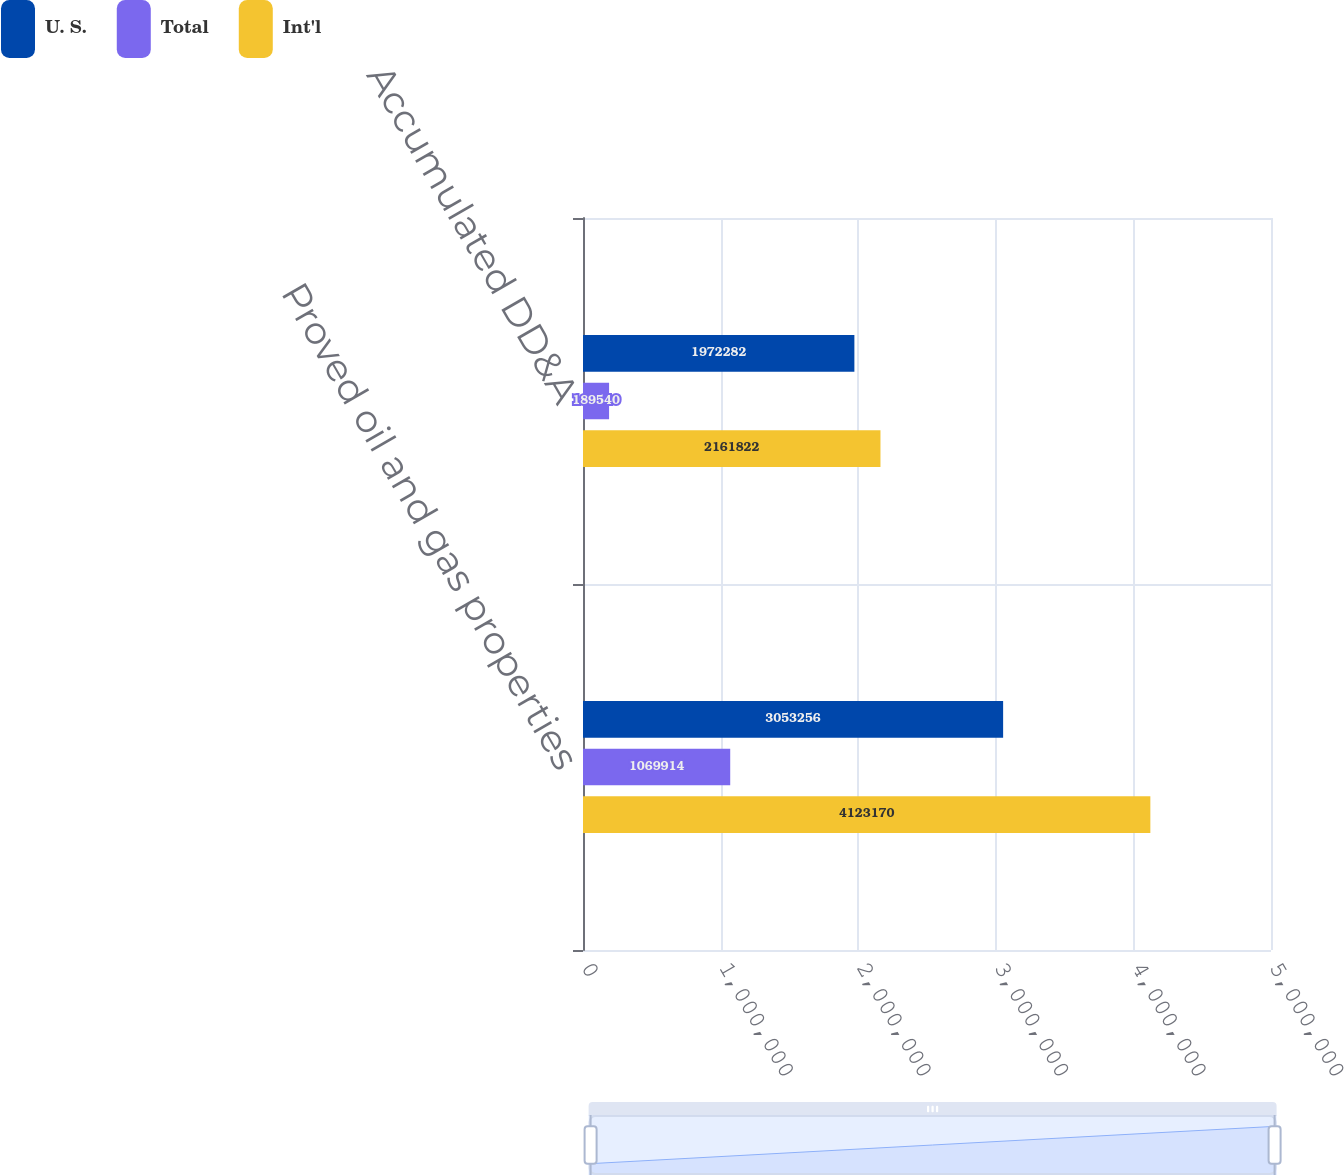<chart> <loc_0><loc_0><loc_500><loc_500><stacked_bar_chart><ecel><fcel>Proved oil and gas properties<fcel>Accumulated DD&A<nl><fcel>U. S.<fcel>3.05326e+06<fcel>1.97228e+06<nl><fcel>Total<fcel>1.06991e+06<fcel>189540<nl><fcel>Int'l<fcel>4.12317e+06<fcel>2.16182e+06<nl></chart> 